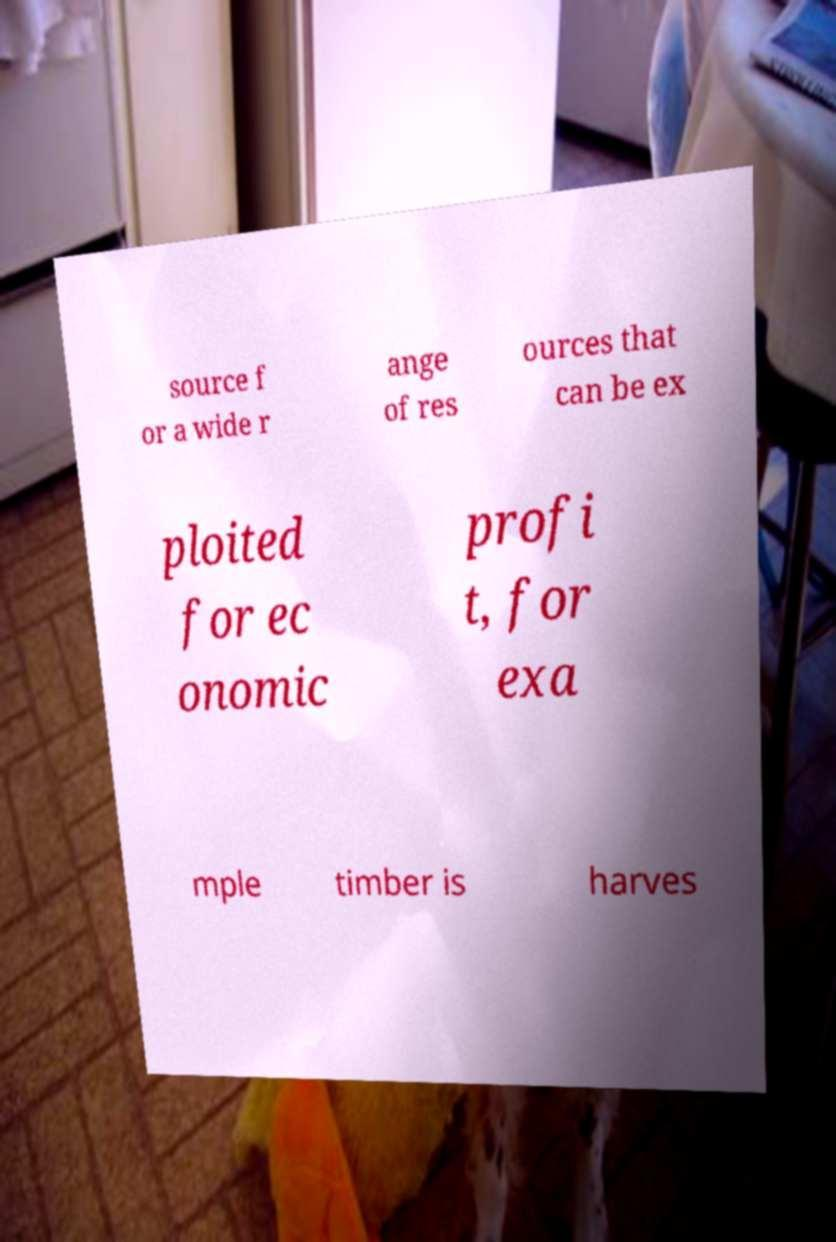Can you read and provide the text displayed in the image?This photo seems to have some interesting text. Can you extract and type it out for me? source f or a wide r ange of res ources that can be ex ploited for ec onomic profi t, for exa mple timber is harves 